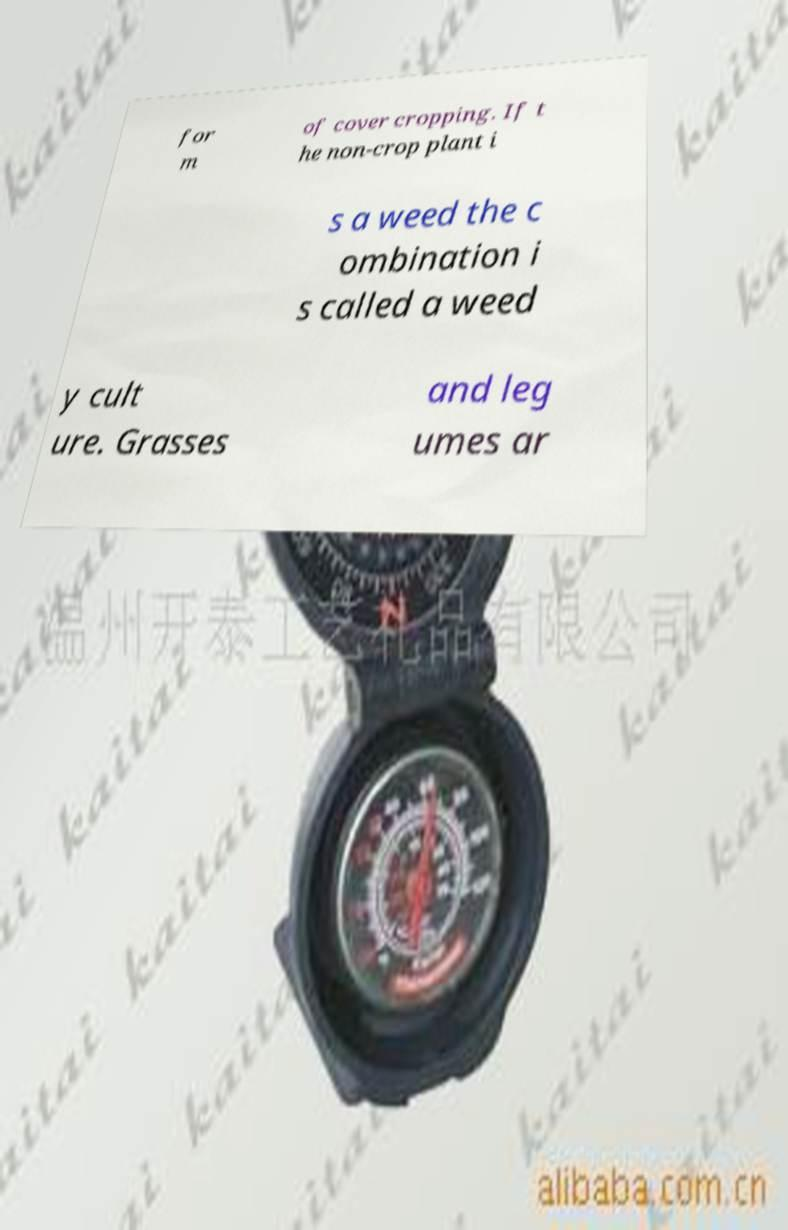I need the written content from this picture converted into text. Can you do that? for m of cover cropping. If t he non-crop plant i s a weed the c ombination i s called a weed y cult ure. Grasses and leg umes ar 